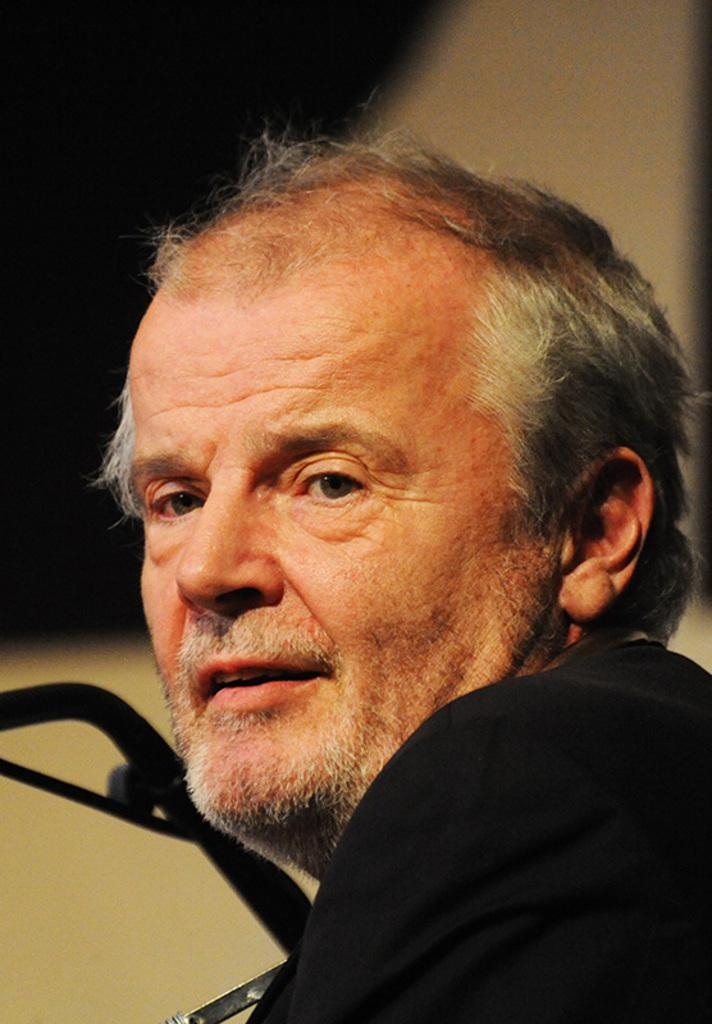Who is present in the image? There is a man in the image. What is the man wearing? The man is wearing a black jacket. What can be seen in the background of the image? There is a wall in the background of the image. How is the background of the image depicted? The background is slightly blurred. What song is the man singing in the image? There is no indication in the image that the man is singing a song, so it cannot be determined from the picture. 